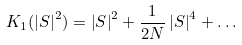Convert formula to latex. <formula><loc_0><loc_0><loc_500><loc_500>K _ { 1 } ( \left | S \right | ^ { 2 } ) = \left | S \right | ^ { 2 } + \frac { 1 } { 2 N } \left | S \right | ^ { 4 } + \dots</formula> 